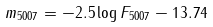Convert formula to latex. <formula><loc_0><loc_0><loc_500><loc_500>m _ { 5 0 0 7 } = - 2 . 5 \log F _ { 5 0 0 7 } - 1 3 . 7 4</formula> 